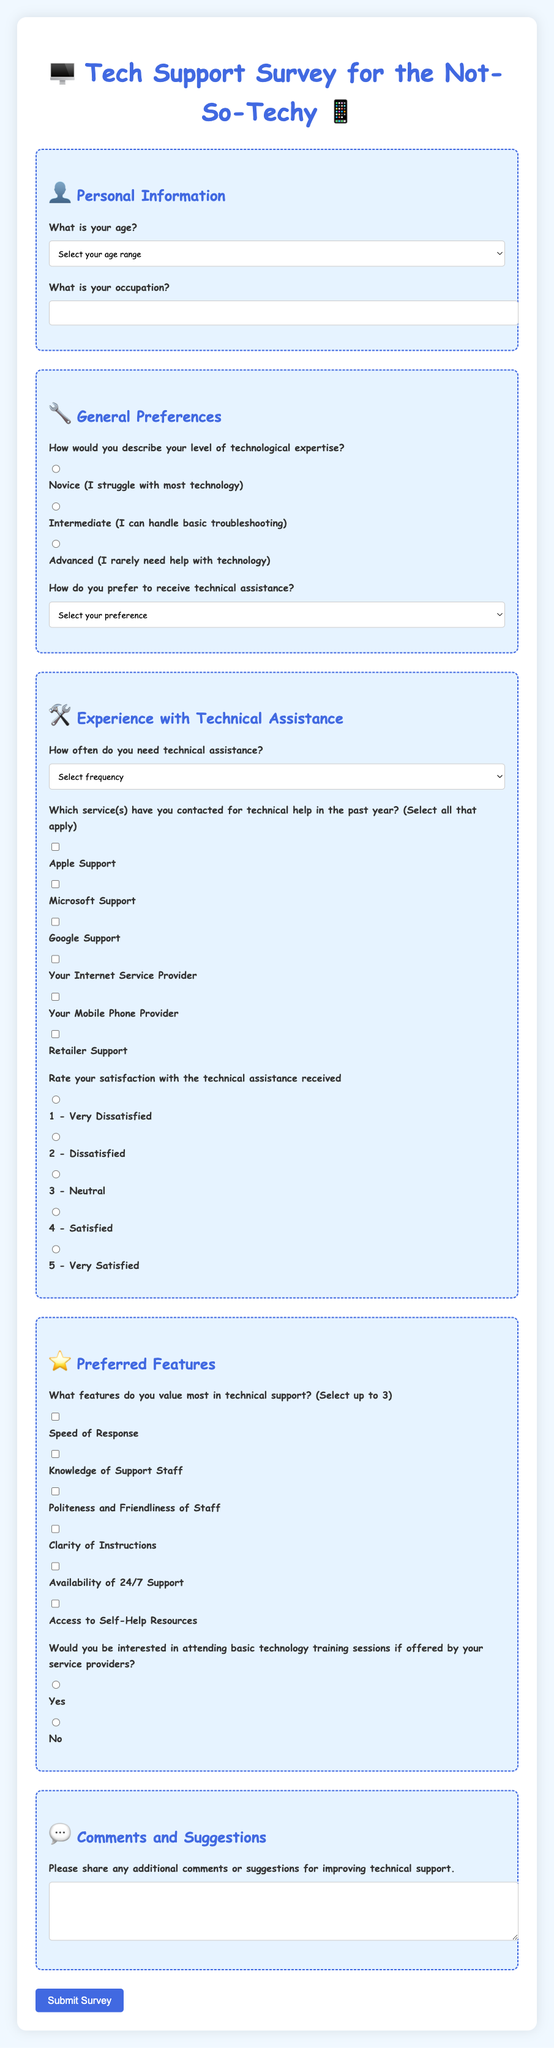What is the title of the survey? The title of the survey is the main heading at the top of the document.
Answer: Tech Support Survey for the Not-So-Techy How many age range options are available? The document lists the age range options provided in a dropdown menu.
Answer: Seven What is the maximum number of features a respondent can select in the Preferred Features section? This question refers to the instructions given in the selection of features to indicate a preference.
Answer: Three What is the lowest satisfaction rating option available? The lowest rating option is defined by the satisfaction scale included in the survey.
Answer: 1 - Very Dissatisfied Which technical support options can respondents select for assistance? These are the choices listed in the General Preferences section of the survey.
Answer: Face-to-Face, Phone, Email, Live Chat, Video Call, Self-Help How often is the "Very Frequently" option defined in the frequency of needing technical assistance? This is detailed in the dropdown menu that describes frequency of technical assistance needed.
Answer: Weekly or more Is there an option for respondents to provide comments? This question is based on whether the document includes a section for additional input from participants.
Answer: Yes Would respondents be interested in basic technology training sessions? This reflects the survey question about interest in training sessions from service providers.
Answer: Yes or No 